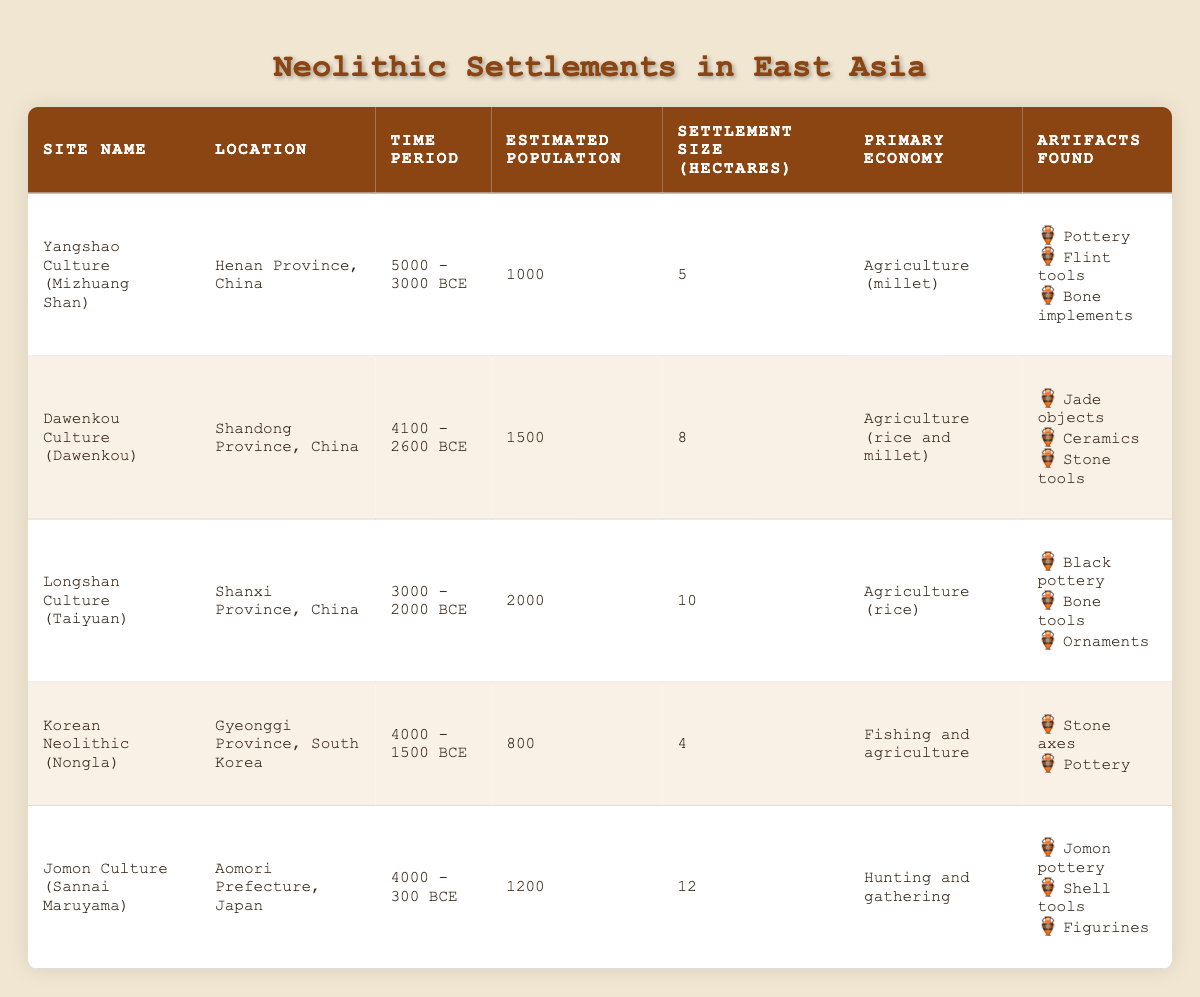What is the estimated population of the Longshan Culture (Taiyuan)? The estimated population for the Longshan Culture (Taiyuan) is stated directly in the table under the "Estimated Population" column. It lists 2000 for this site.
Answer: 2000 Which site has the largest settlement size and what is it? In the table, we look at the "Settlement Size (hectares)" column and find that the Jomon Culture (Sannai Maruyama) has the largest size of 12 hectares.
Answer: Jomon Culture (Sannai Maruyama), 12 hectares How many artifacts were found at the Dawenkou Culture site? The Dawenkou Culture site lists three artifacts in the "Artifacts Found" section: Jade objects, Ceramics, and Stone tools. This indicates a total of 3 artifacts found there.
Answer: 3 Is the primary economy of the Yangshao Culture (Mizhuang Shan) agriculture-based? The data indicates that the primary economy of the Yangshao Culture is Agriculture (millet), which confirms it is indeed agriculture-based.
Answer: Yes What is the average estimated population of the Neolithic settlements listed? To find the average, we sum up the estimated populations of all the sites: 1000 + 1500 + 2000 + 800 + 1200 = 6500. Then we divide this total by the number of sites (5), so 6500 / 5 = 1300.
Answer: 1300 Which site has the smallest estimated population and what is the value? Referring to the "Estimated Population" column, the smallest population listed is for the Korean Neolithic (Nongla) at 800.
Answer: Korean Neolithic (Nongla), 800 How many settlements have an estimated population greater than 1000? Reviewing the "Estimated Population" column, the sites with populations greater than 1000 are Dawenkou Culture (1500), Longshan Culture (2000), and Jomon Culture (1200), totaling 3 sites.
Answer: 3 What is the difference in settlement size between the largest (Jomon Culture) and the smallest (Korean Neolithic)? The largest settlement size is 12 hectares (Jomon Culture) and the smallest is 4 hectares (Korean Neolithic). The difference is 12 - 4 = 8 hectares.
Answer: 8 hectares Which primary economy is associated with the Jomon Culture? The table indicates that the primary economy of the Jomon Culture (Sannai Maruyama) is Hunting and gathering.
Answer: Hunting and gathering 